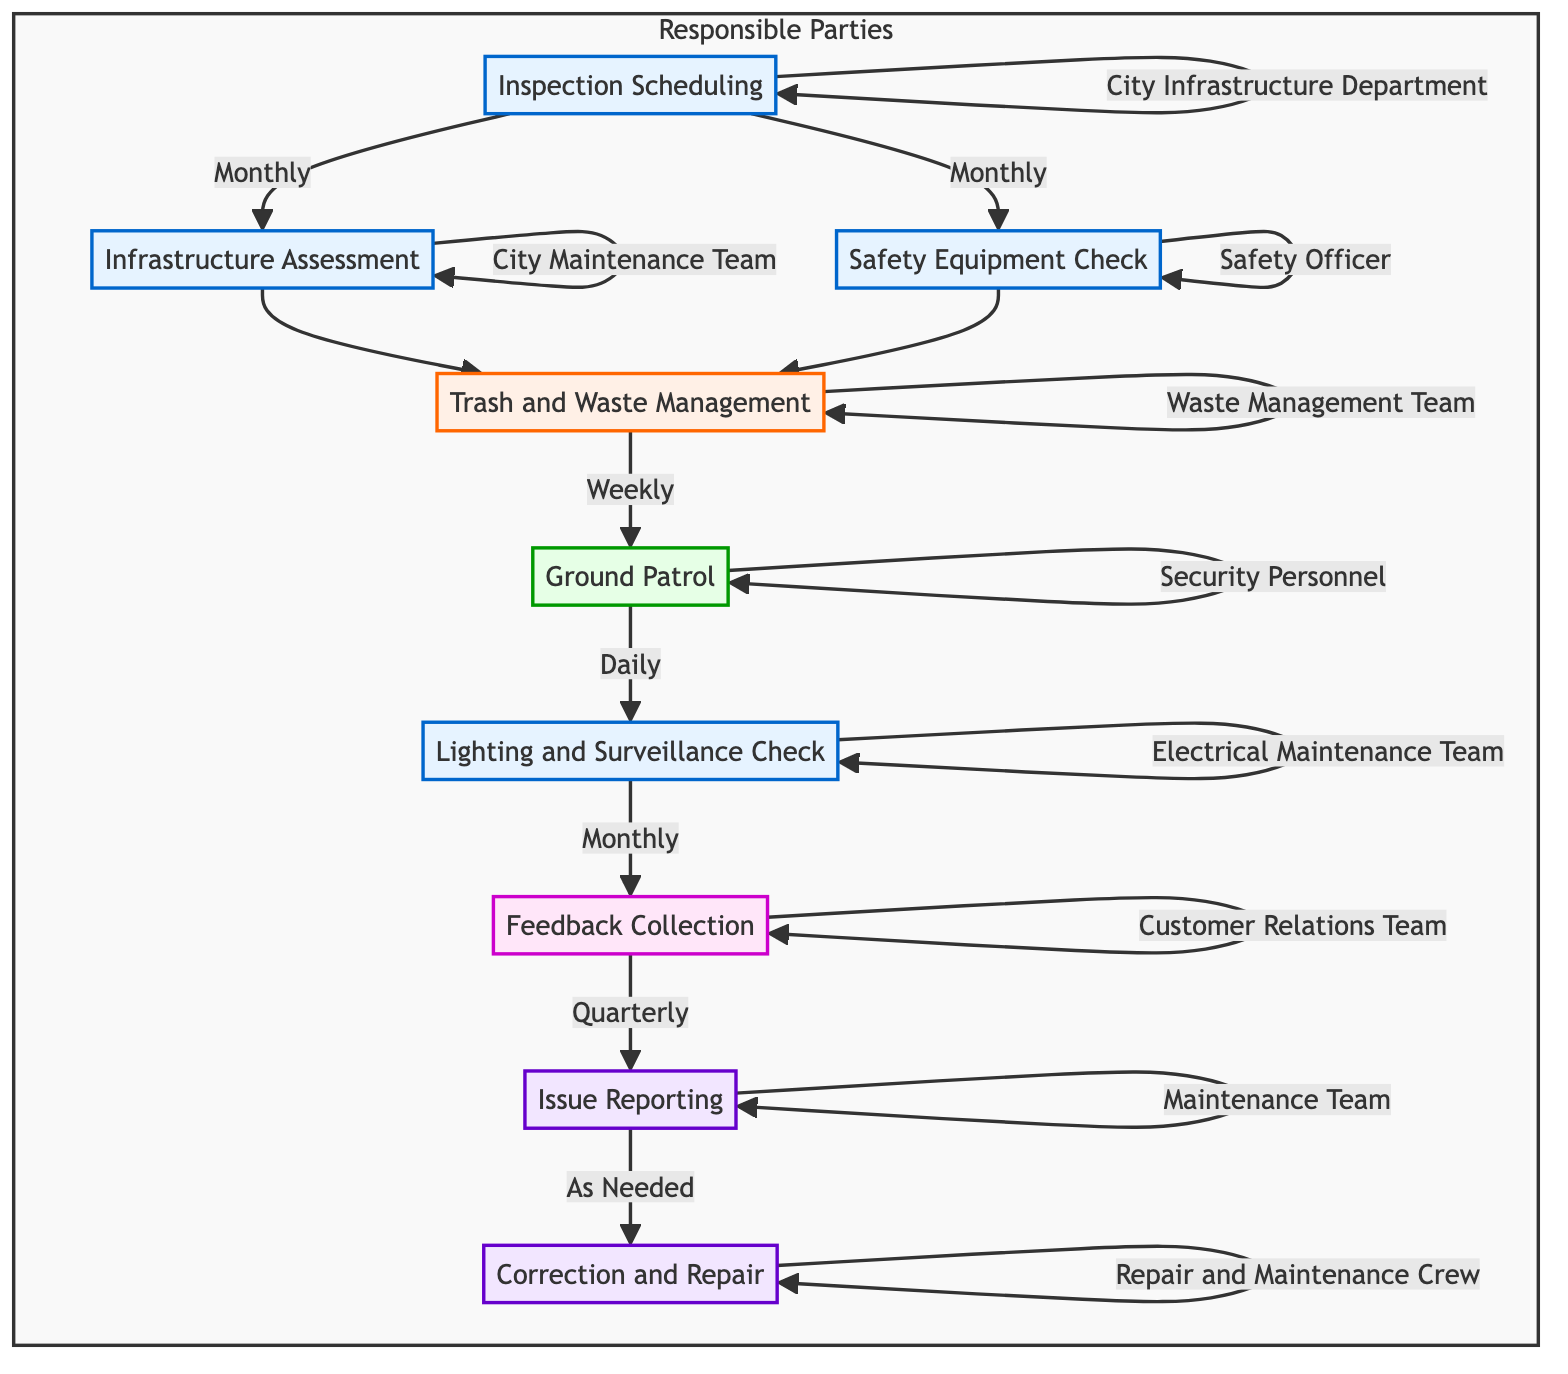What is the first step in the pathway? The diagram indicates that the first step is "Inspection Scheduling." This can be confirmed by looking at the starting node in the diagram.
Answer: Inspection Scheduling How often is the "Trash and Waste Management" step performed? By examining the node for "Trash and Waste Management," the diagram shows it is performed weekly. This follows the connections from the previous steps.
Answer: Weekly Who is responsible for the "Infrastructure Assessment" step? The diagram specifies that the responsibility for "Infrastructure Assessment" lies with the "City Maintenance Team." This can be found in the subgraph of responsible parties.
Answer: City Maintenance Team What is the timeframe for "Feedback Collection"? Looking at the node for "Feedback Collection," it shows the timeframe is quarterly according to the edge linked to it.
Answer: Quarterly Which step follows "Ground Patrol" in the diagram? The next step after "Ground Patrol" is "Lighting and Surveillance Check," which can be inferred from the direct link flowing from "Ground Patrol" to "Lighting and Surveillance Check."
Answer: Lighting and Surveillance Check How many steps require monthly checkups? Counting the nodes labeled with "Monthly" shows that there are five steps that have this frequency: "Inspection Scheduling," "Infrastructure Assessment," "Safety Equipment Check," "Lighting and Surveillance Check," and "Ground Patrol."
Answer: Five What action is taken "As Needed"? According to the diagram, the action taken "As Needed" is "Issue Reporting." This shows the flexibility of timing related to issues found.
Answer: Issue Reporting What is the maximum timeframe allowed for "Correction and Repair"? The diagram states that "Correction and Repair" must be done within 48 hours of a report, which implies a strict timeframe for urgent issues.
Answer: Within 48 Hours of Report How does the "Safety Equipment Check" relate to "Trash and Waste Management"? Both "Safety Equipment Check" and "Infrastructure Assessment" lead to "Trash and Waste Management," indicating they are prerequisites for this step, highlighting the intertwined nature of safety and cleanliness.
Answer: They are prerequisites Which team is responsible for collecting feedback? The responsible party for collecting feedback is the "Customer Relations Team," as indicated in the diagram's responsible parties section linked to "Feedback Collection."
Answer: Customer Relations Team 